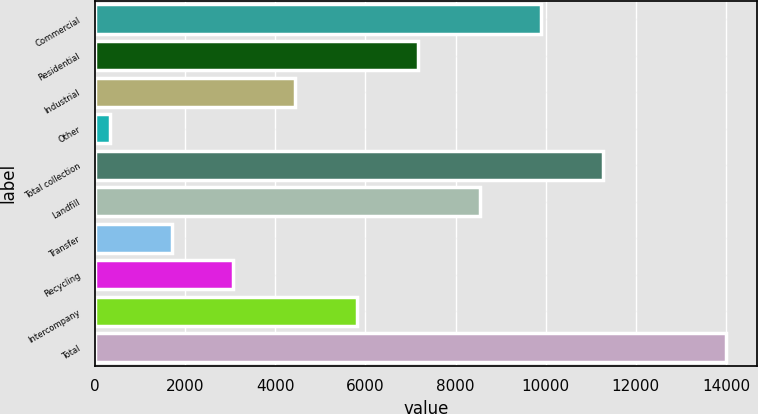<chart> <loc_0><loc_0><loc_500><loc_500><bar_chart><fcel>Commercial<fcel>Residential<fcel>Industrial<fcel>Other<fcel>Total collection<fcel>Landfill<fcel>Transfer<fcel>Recycling<fcel>Intercompany<fcel>Total<nl><fcel>9899.2<fcel>7168<fcel>4436.8<fcel>340<fcel>11264.8<fcel>8533.6<fcel>1705.6<fcel>3071.2<fcel>5802.4<fcel>13996<nl></chart> 